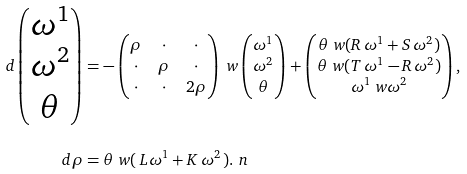<formula> <loc_0><loc_0><loc_500><loc_500>d \begin{pmatrix} \omega ^ { 1 } \\ \omega ^ { 2 } \\ \theta \end{pmatrix} & = - \begin{pmatrix} \rho & \cdot & \cdot \\ \cdot & \rho & \cdot \\ \cdot & \cdot & 2 \rho \end{pmatrix} \ w \begin{pmatrix} \omega ^ { 1 } \\ \omega ^ { 2 } \\ \theta \end{pmatrix} + \begin{pmatrix} \theta \ w ( R \, \omega ^ { 1 } + S \, \omega ^ { 2 } ) \\ \theta \ w ( T \, \omega ^ { 1 } - R \, \omega ^ { 2 } ) \\ \omega ^ { 1 } \ w \omega ^ { 2 } \end{pmatrix} , \\ d \rho & = \theta \ w ( \, L \omega ^ { 1 } + K \, \omega ^ { 2 } \, ) . \ n</formula> 